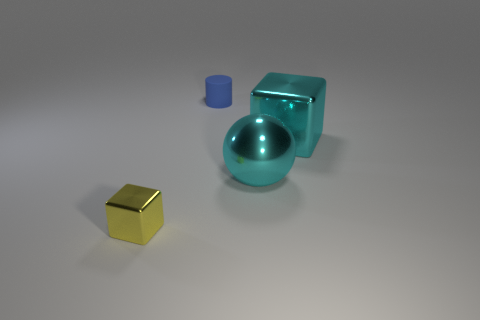Add 4 shiny blocks. How many objects exist? 8 Subtract all spheres. How many objects are left? 3 Subtract all red cylinders. Subtract all yellow metal cubes. How many objects are left? 3 Add 4 yellow things. How many yellow things are left? 5 Add 3 tiny metallic blocks. How many tiny metallic blocks exist? 4 Subtract 0 yellow cylinders. How many objects are left? 4 